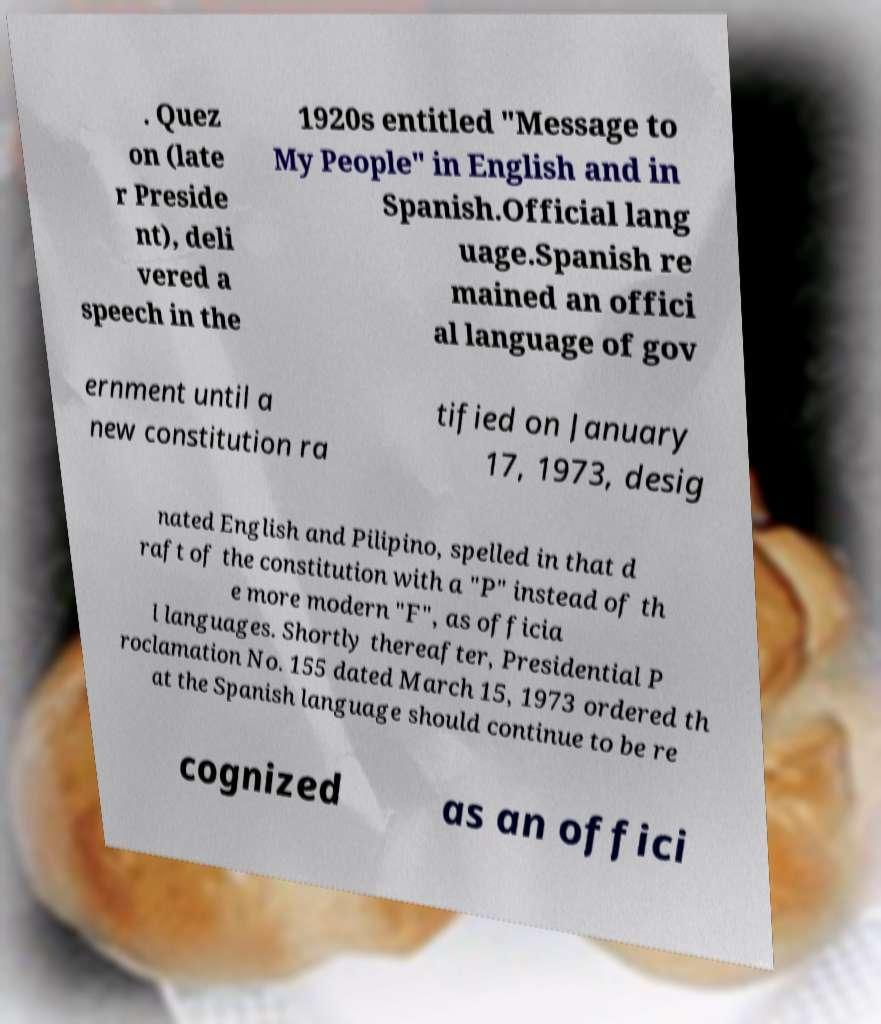There's text embedded in this image that I need extracted. Can you transcribe it verbatim? . Quez on (late r Preside nt), deli vered a speech in the 1920s entitled "Message to My People" in English and in Spanish.Official lang uage.Spanish re mained an offici al language of gov ernment until a new constitution ra tified on January 17, 1973, desig nated English and Pilipino, spelled in that d raft of the constitution with a "P" instead of th e more modern "F", as officia l languages. Shortly thereafter, Presidential P roclamation No. 155 dated March 15, 1973 ordered th at the Spanish language should continue to be re cognized as an offici 